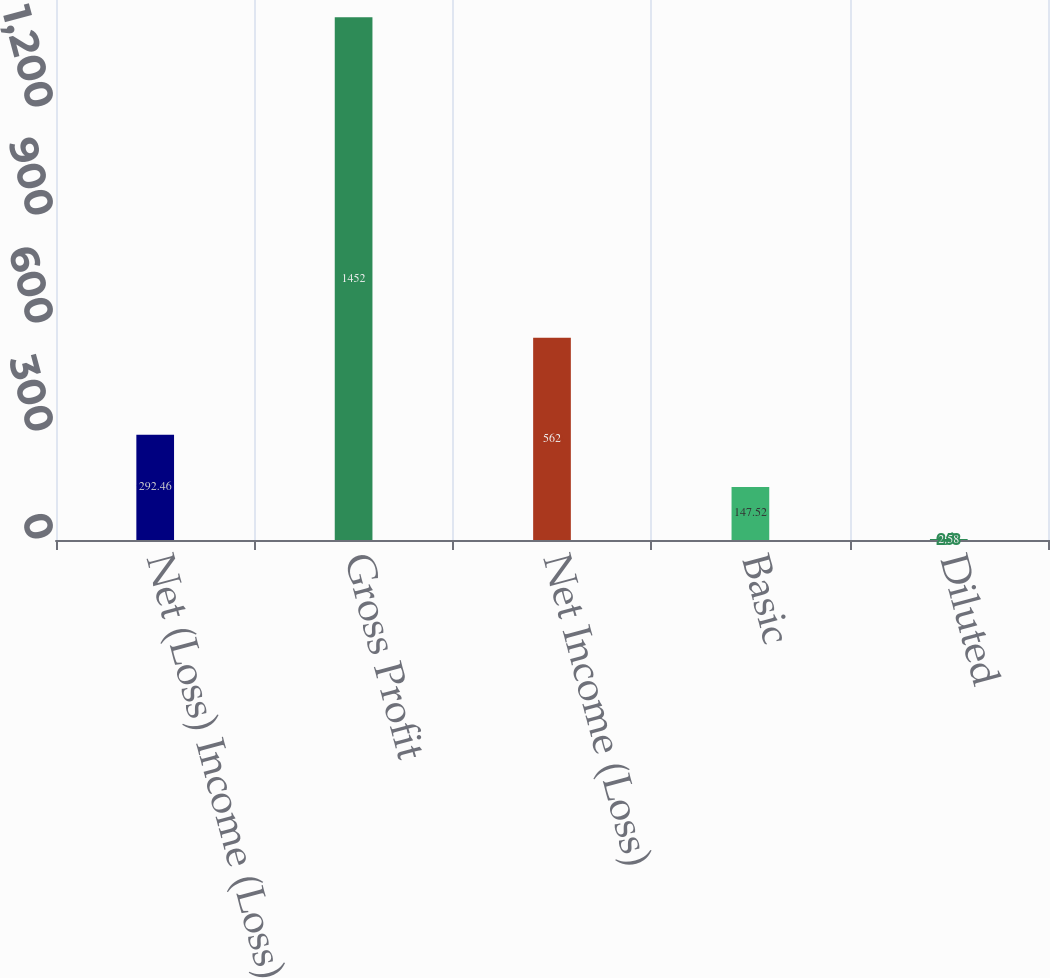Convert chart. <chart><loc_0><loc_0><loc_500><loc_500><bar_chart><fcel>Net (Loss) Income (Loss)<fcel>Gross Profit<fcel>Net Income (Loss)<fcel>Basic<fcel>Diluted<nl><fcel>292.46<fcel>1452<fcel>562<fcel>147.52<fcel>2.58<nl></chart> 